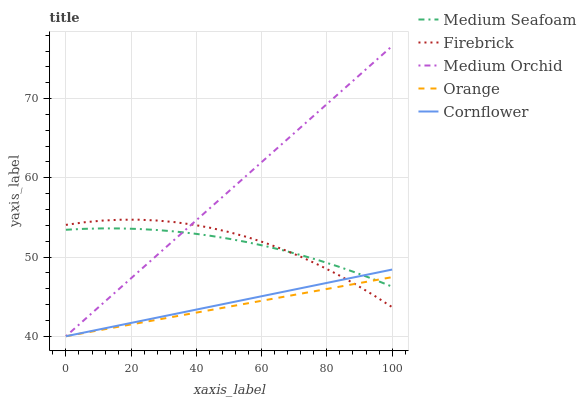Does Orange have the minimum area under the curve?
Answer yes or no. Yes. Does Medium Orchid have the maximum area under the curve?
Answer yes or no. Yes. Does Cornflower have the minimum area under the curve?
Answer yes or no. No. Does Cornflower have the maximum area under the curve?
Answer yes or no. No. Is Medium Orchid the smoothest?
Answer yes or no. Yes. Is Firebrick the roughest?
Answer yes or no. Yes. Is Cornflower the smoothest?
Answer yes or no. No. Is Cornflower the roughest?
Answer yes or no. No. Does Orange have the lowest value?
Answer yes or no. Yes. Does Firebrick have the lowest value?
Answer yes or no. No. Does Medium Orchid have the highest value?
Answer yes or no. Yes. Does Cornflower have the highest value?
Answer yes or no. No. Does Medium Orchid intersect Medium Seafoam?
Answer yes or no. Yes. Is Medium Orchid less than Medium Seafoam?
Answer yes or no. No. Is Medium Orchid greater than Medium Seafoam?
Answer yes or no. No. 